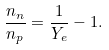<formula> <loc_0><loc_0><loc_500><loc_500>\frac { n _ { n } } { n _ { p } } = \frac { 1 } { Y _ { e } } - 1 .</formula> 